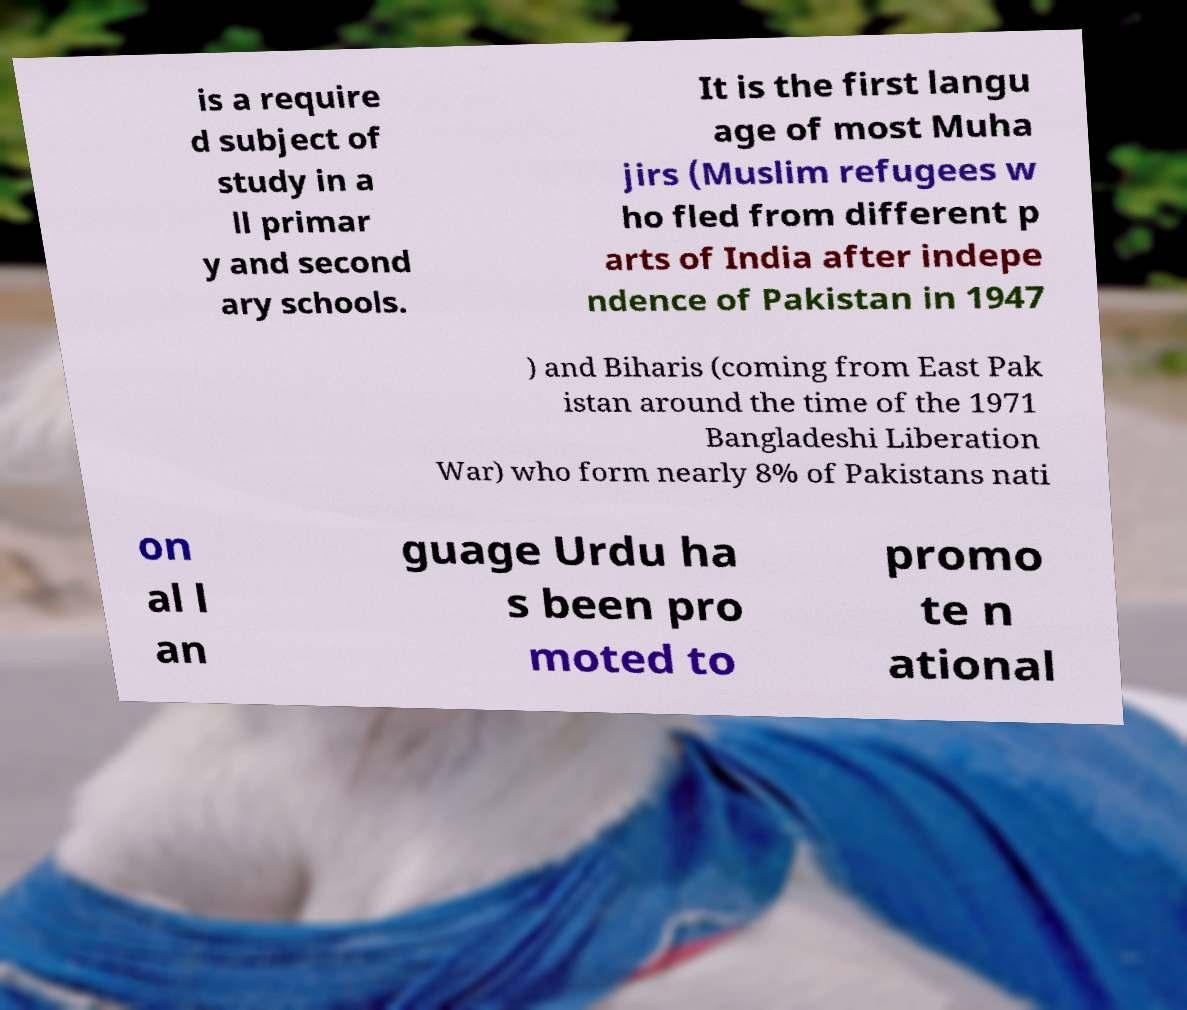Could you assist in decoding the text presented in this image and type it out clearly? is a require d subject of study in a ll primar y and second ary schools. It is the first langu age of most Muha jirs (Muslim refugees w ho fled from different p arts of India after indepe ndence of Pakistan in 1947 ) and Biharis (coming from East Pak istan around the time of the 1971 Bangladeshi Liberation War) who form nearly 8% of Pakistans nati on al l an guage Urdu ha s been pro moted to promo te n ational 